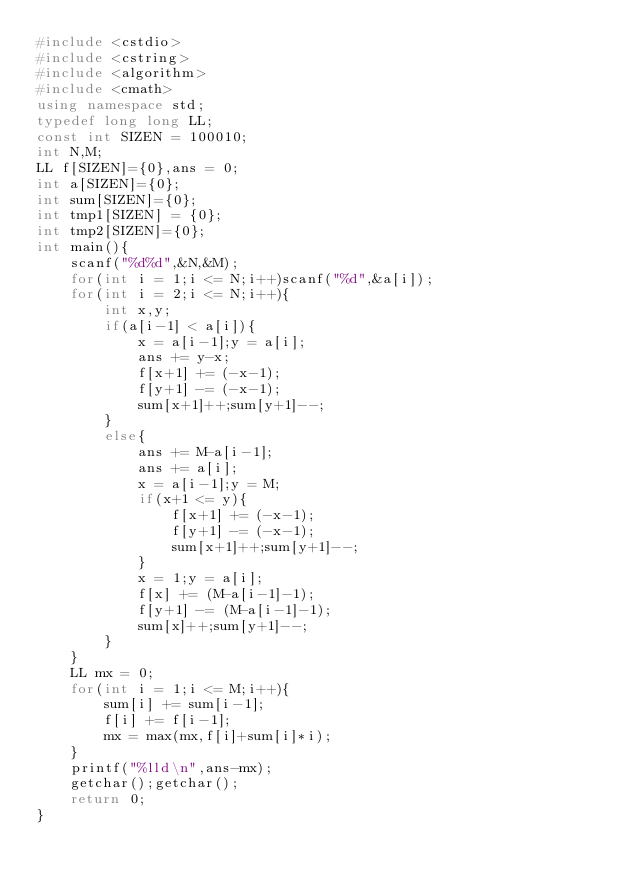<code> <loc_0><loc_0><loc_500><loc_500><_C++_>#include <cstdio>
#include <cstring>
#include <algorithm>
#include <cmath>
using namespace std;
typedef long long LL;
const int SIZEN = 100010;
int N,M;
LL f[SIZEN]={0},ans = 0;
int a[SIZEN]={0};
int sum[SIZEN]={0};
int tmp1[SIZEN] = {0};
int tmp2[SIZEN]={0};
int main(){
	scanf("%d%d",&N,&M);
	for(int i = 1;i <= N;i++)scanf("%d",&a[i]);
	for(int i = 2;i <= N;i++){
		int x,y;
		if(a[i-1] < a[i]){
			x = a[i-1];y = a[i];
			ans += y-x;
			f[x+1] += (-x-1);
			f[y+1] -= (-x-1);
			sum[x+1]++;sum[y+1]--;
		}	
		else{
			ans += M-a[i-1];
			ans += a[i];
			x = a[i-1];y = M;
			if(x+1 <= y){
				f[x+1] += (-x-1);
				f[y+1] -= (-x-1);
				sum[x+1]++;sum[y+1]--;
			}
			x = 1;y = a[i];
			f[x] += (M-a[i-1]-1);
			f[y+1] -= (M-a[i-1]-1);
			sum[x]++;sum[y+1]--;	
		}
	}
	LL mx = 0;
	for(int i = 1;i <= M;i++){
		sum[i] += sum[i-1];
		f[i] += f[i-1];
		mx = max(mx,f[i]+sum[i]*i);
	}
	printf("%lld\n",ans-mx);
	getchar();getchar();
	return 0;
}
</code> 